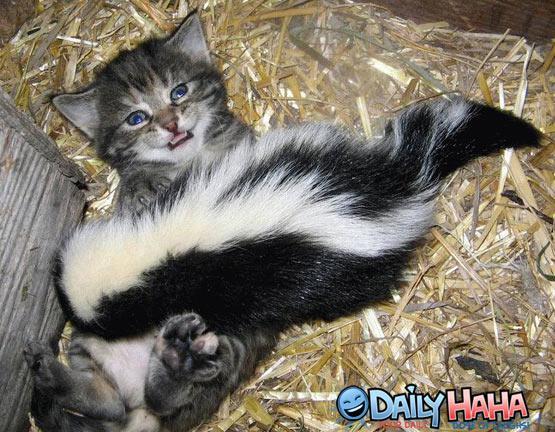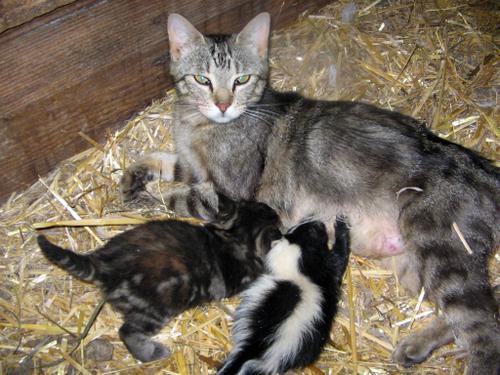The first image is the image on the left, the second image is the image on the right. For the images displayed, is the sentence "There is more than one species of animal." factually correct? Answer yes or no. Yes. The first image is the image on the left, the second image is the image on the right. Assess this claim about the two images: "One image shows a reclining mother cat with a kitten and a skunk in front of it.". Correct or not? Answer yes or no. Yes. 